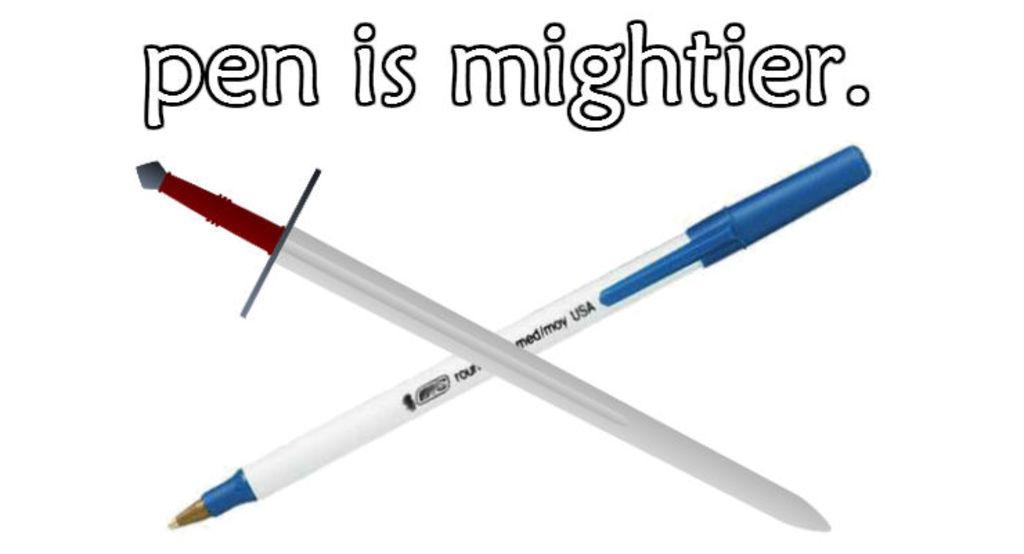Please provide a concise description of this image. In this image I see a pen which is of white and blue in color and I see few words written over here and I see a sword over here which is of grey, red and white in color and I see the watermark over here and it is white in the background. 